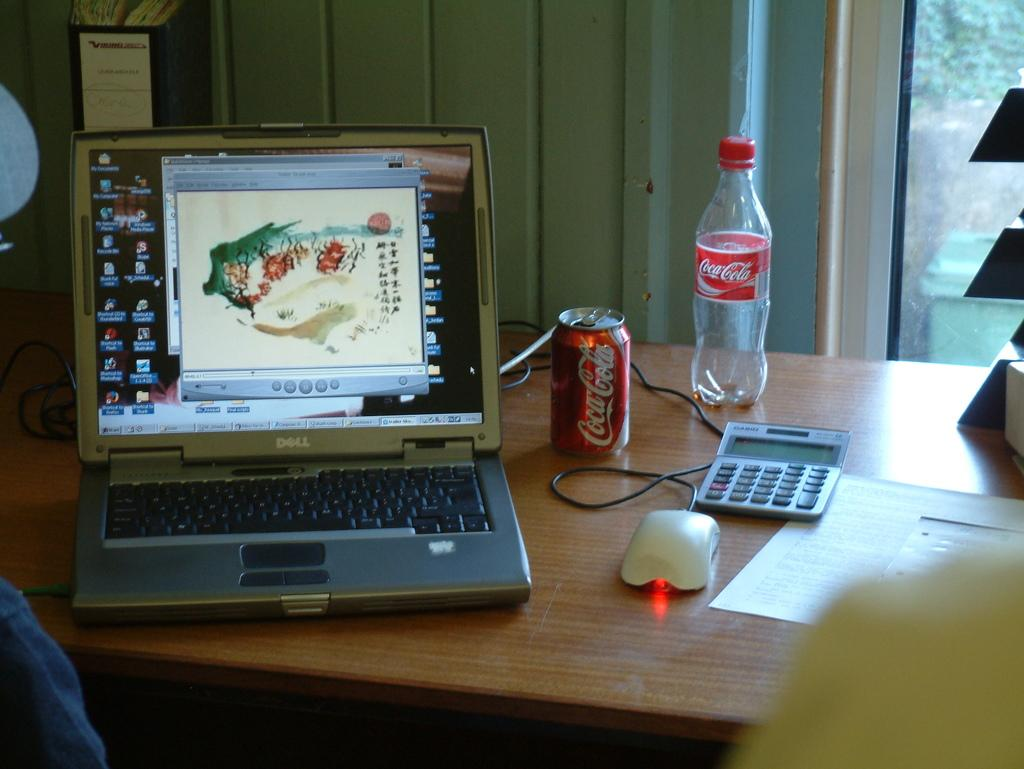What type of structure can be seen in the image? There is a wall in the image. What piece of furniture is present in the image? There is a table in the image. What electronic device is on the table? There is a laptop on the table. What other objects are on the table? There is a tin, a bottle, a calculator, a mouse, and a paper on the table. Can you see any ocean waves in the image? There is no ocean or waves present in the image. Is there a squirrel sitting on the table in the image? There is no squirrel present in the image. 